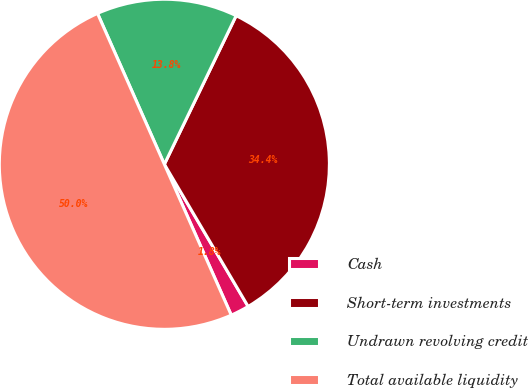<chart> <loc_0><loc_0><loc_500><loc_500><pie_chart><fcel>Cash<fcel>Short-term investments<fcel>Undrawn revolving credit<fcel>Total available liquidity<nl><fcel>1.83%<fcel>34.36%<fcel>13.8%<fcel>50.0%<nl></chart> 